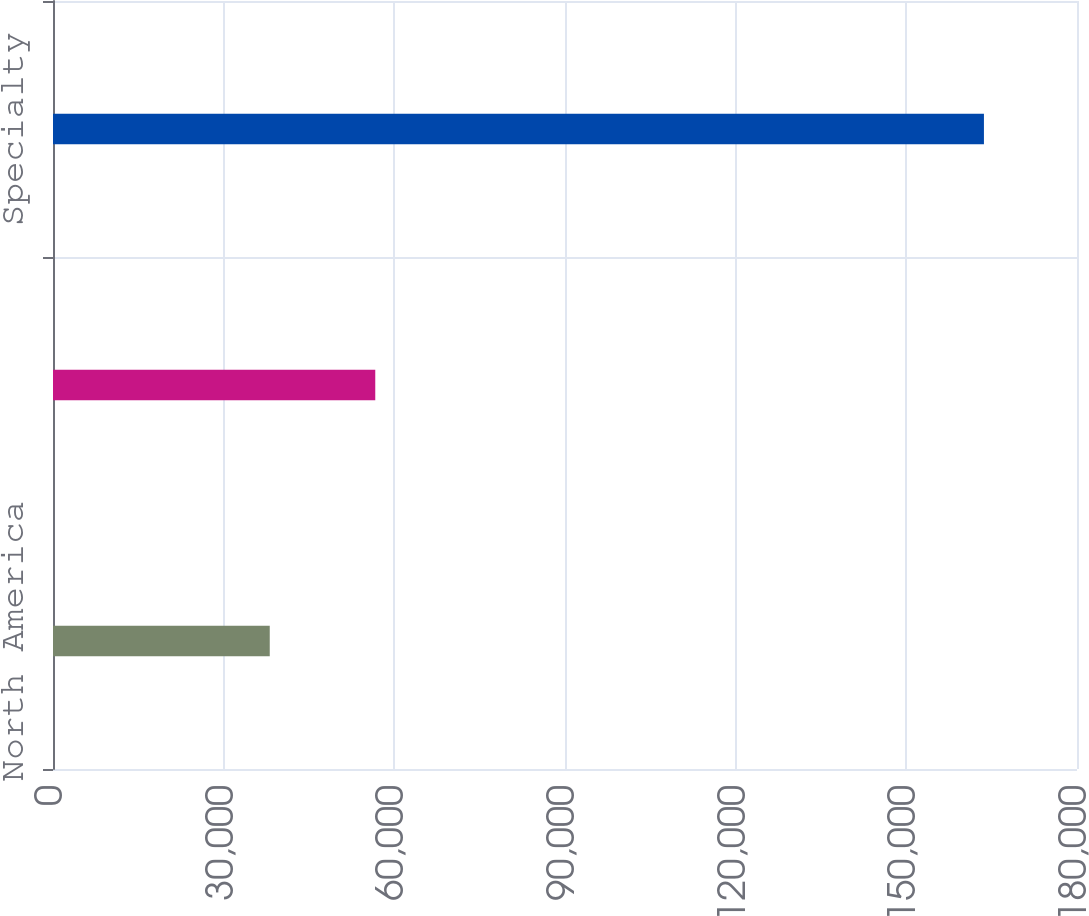<chart> <loc_0><loc_0><loc_500><loc_500><bar_chart><fcel>North America<fcel>Europe<fcel>Specialty<nl><fcel>38100<fcel>56648<fcel>163641<nl></chart> 